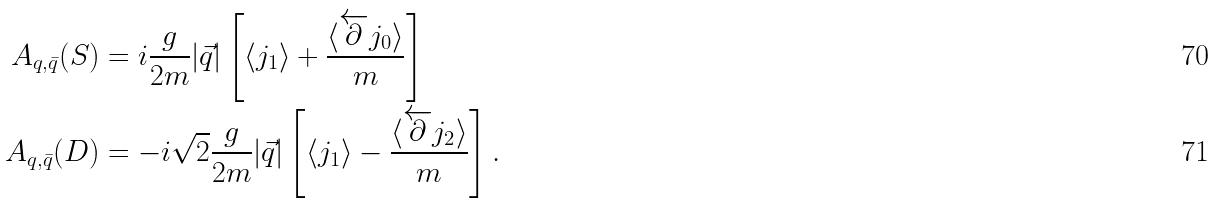<formula> <loc_0><loc_0><loc_500><loc_500>A _ { q , \bar { q } } ( S ) & = i \frac { g } { 2 m } | \vec { q } | \left [ \langle j _ { 1 } \rangle + \frac { \langle \overleftarrow { \partial } j _ { 0 } \rangle } { m } \right ] \\ A _ { q , \bar { q } } ( D ) & = - i \sqrt { 2 } \frac { g } { 2 m } | \vec { q } | \left [ \langle j _ { 1 } \rangle - \frac { \langle \overleftarrow { \partial } j _ { 2 } \rangle } { m } \right ] .</formula> 